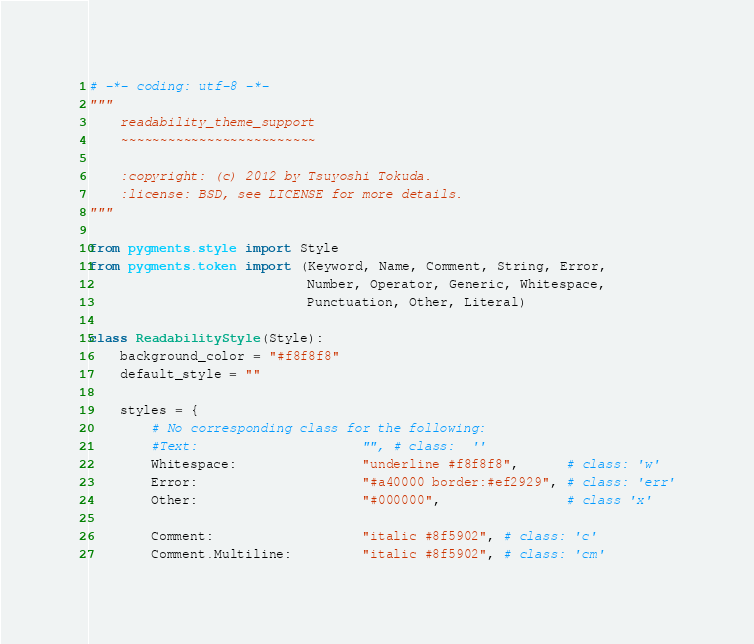Convert code to text. <code><loc_0><loc_0><loc_500><loc_500><_Python_># -*- coding: utf-8 -*-
"""
    readability_theme_support
    ~~~~~~~~~~~~~~~~~~~~~~~~~

    :copyright: (c) 2012 by Tsuyoshi Tokuda.
    :license: BSD, see LICENSE for more details.
"""

from pygments.style import Style
from pygments.token import (Keyword, Name, Comment, String, Error,
                            Number, Operator, Generic, Whitespace,
                            Punctuation, Other, Literal)

class ReadabilityStyle(Style):
    background_color = "#f8f8f8"
    default_style = ""

    styles = {
        # No corresponding class for the following:
        #Text:                     "", # class:  ''
        Whitespace:                "underline #f8f8f8",      # class: 'w'
        Error:                     "#a40000 border:#ef2929", # class: 'err'
        Other:                     "#000000",                # class 'x'

        Comment:                   "italic #8f5902", # class: 'c'
        Comment.Multiline:         "italic #8f5902", # class: 'cm'</code> 